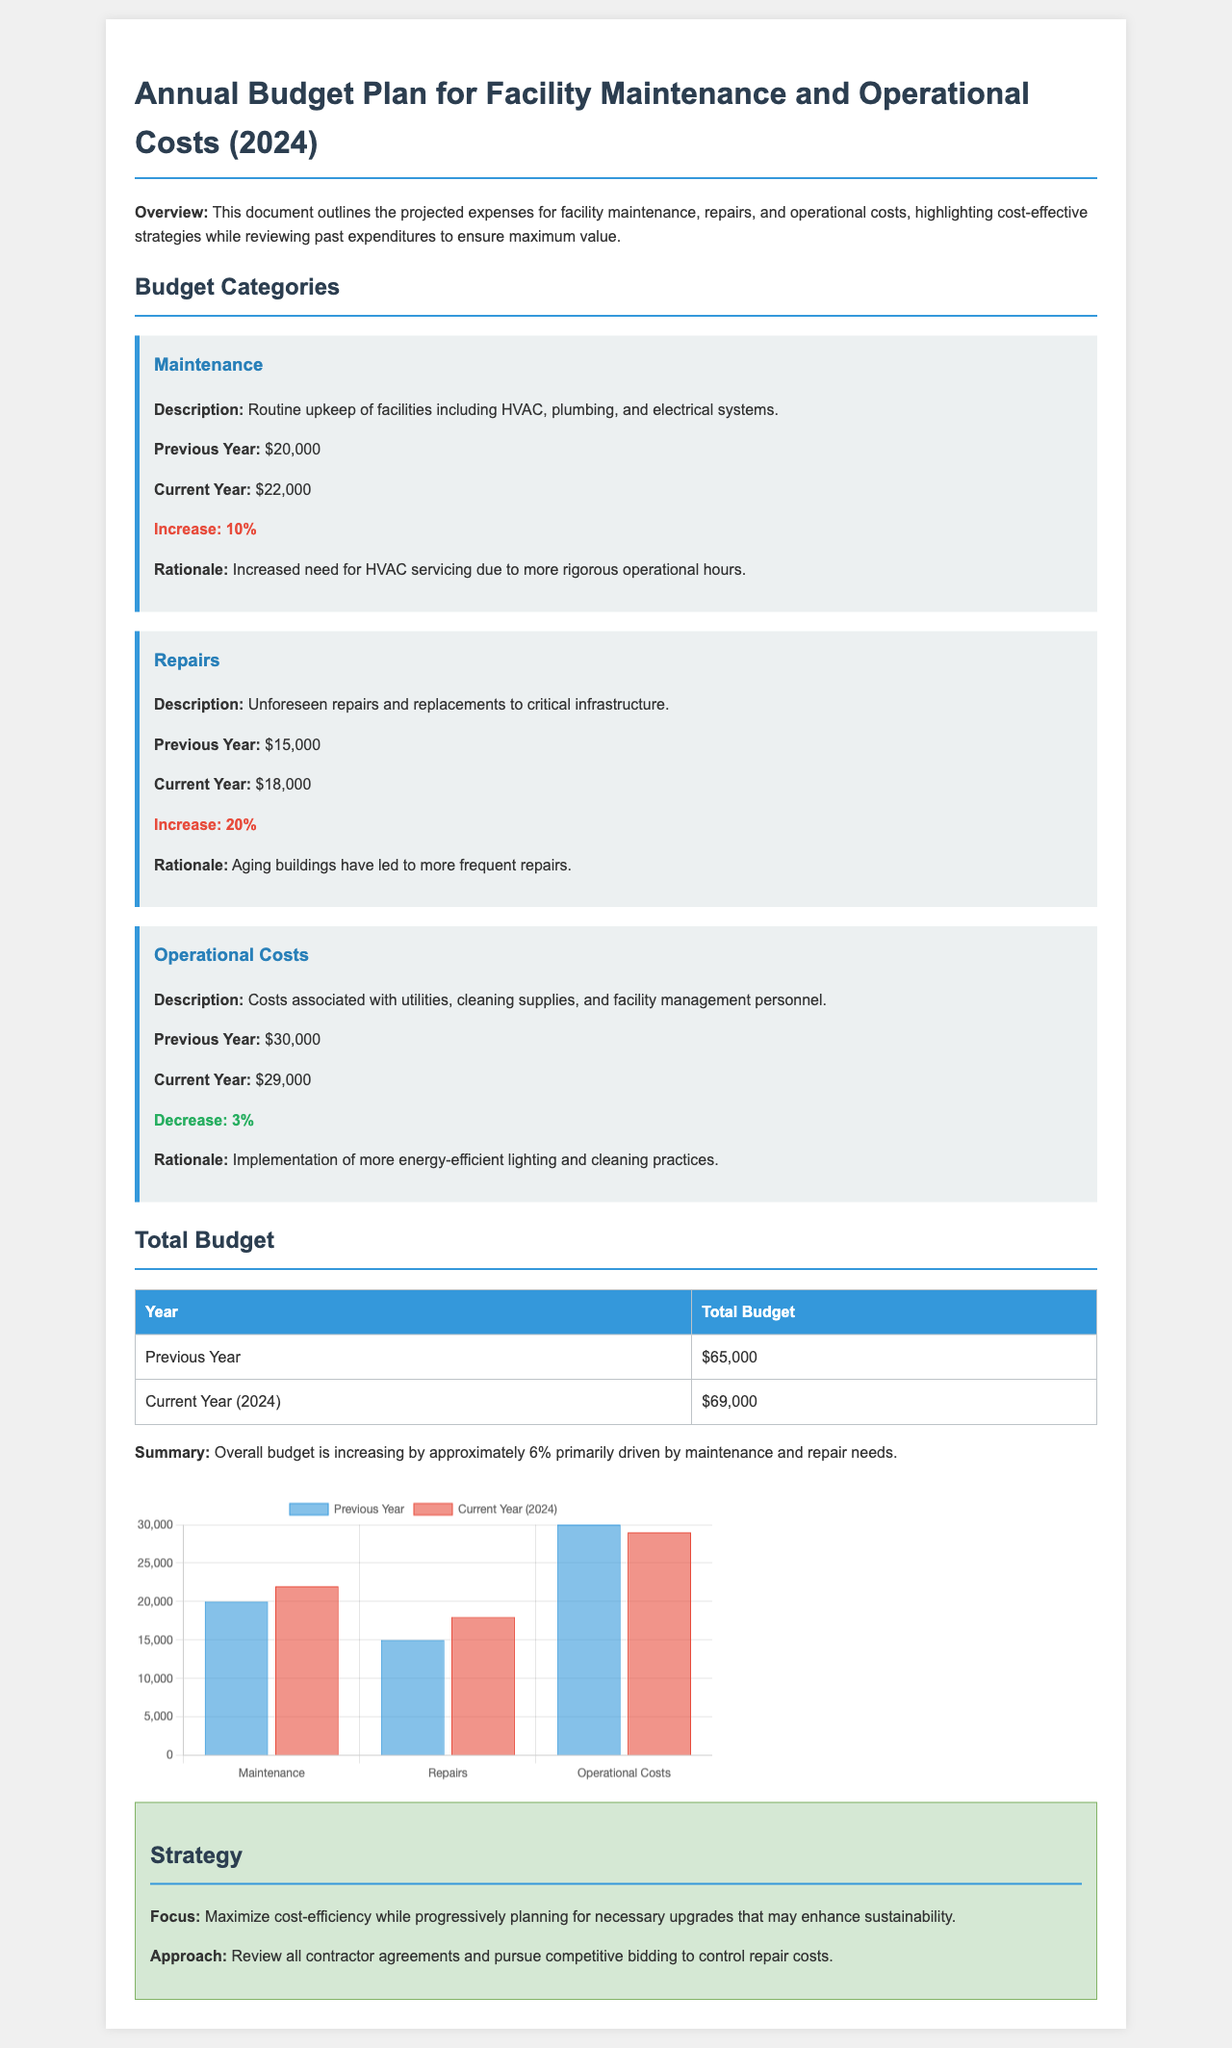What is the total budget for the current year? The total budget for the current year is stated in the table of total budgets.
Answer: $69,000 What is the increase percentage for maintenance costs? The increase percentage for maintenance costs is calculated from the previous year to the current year, which is 10%.
Answer: 10% What was the operational costs for the previous year? The operational costs for the previous year is explicitly mentioned in the budget categories section.
Answer: $30,000 What is the rationale for the increase in repair costs? The rationale is provided in the budget categories section under repairs, explaining the increase is due to aging buildings.
Answer: Aging buildings What is the decrease percentage for operational costs? The decrease percentage for operational costs is noted in the operational costs category, which is 3%.
Answer: 3% What was the budget for repairs in the previous year? The budget for repairs in the previous year can be found in the repairs category.
Answer: $15,000 What is the focus of the strategy outlined in the document? The focus of the strategy is mentioned at the beginning of the strategy section.
Answer: Maximize cost-efficiency How many budget categories are detailed in the document? The number of budget categories is identified in the budget categories section of the document.
Answer: Three What colors represent the current year's budget in the chart? The colors representing the current year's budget in the chart are identified in the chart description and labels.
Answer: Red 